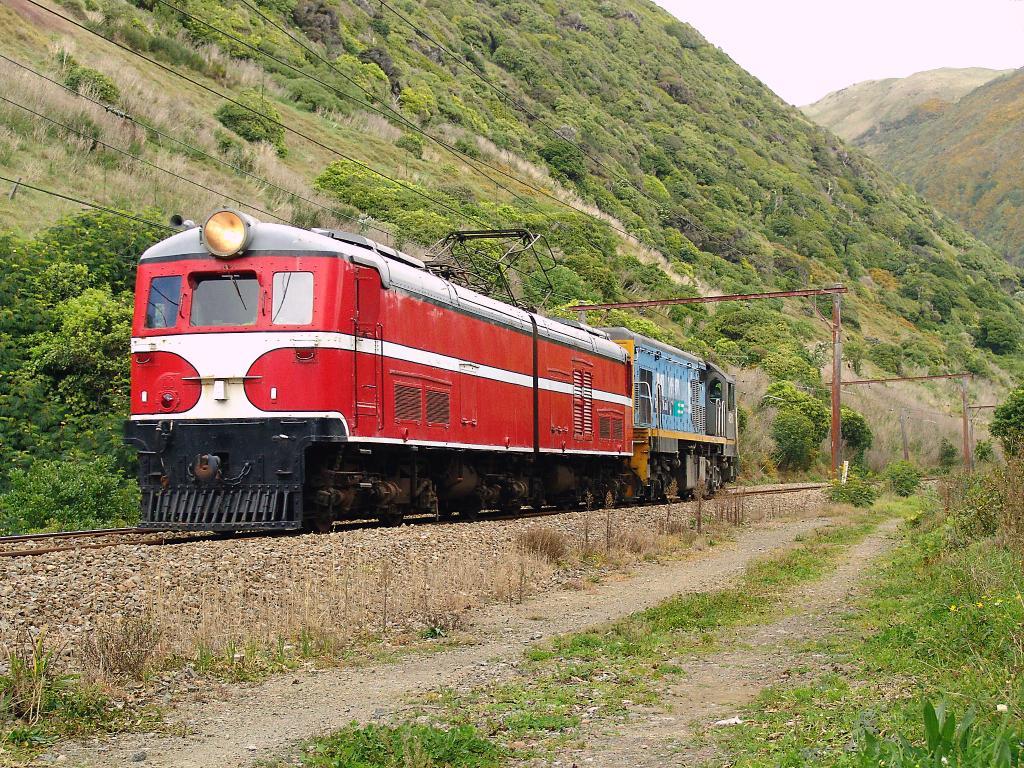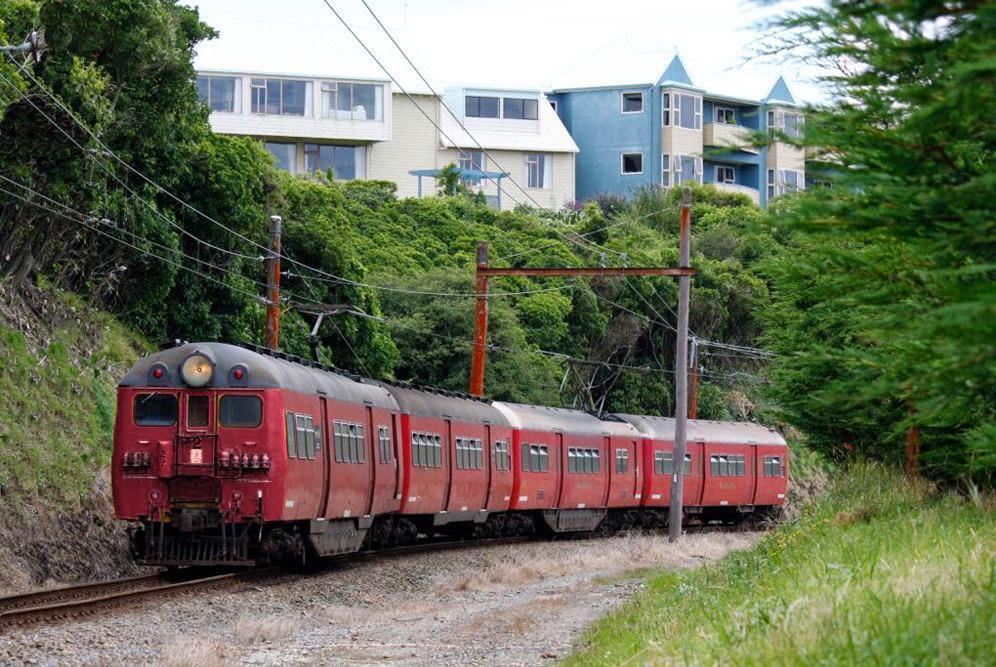The first image is the image on the left, the second image is the image on the right. For the images displayed, is the sentence "The engines in both images are have some red color and are facing to the left." factually correct? Answer yes or no. Yes. 